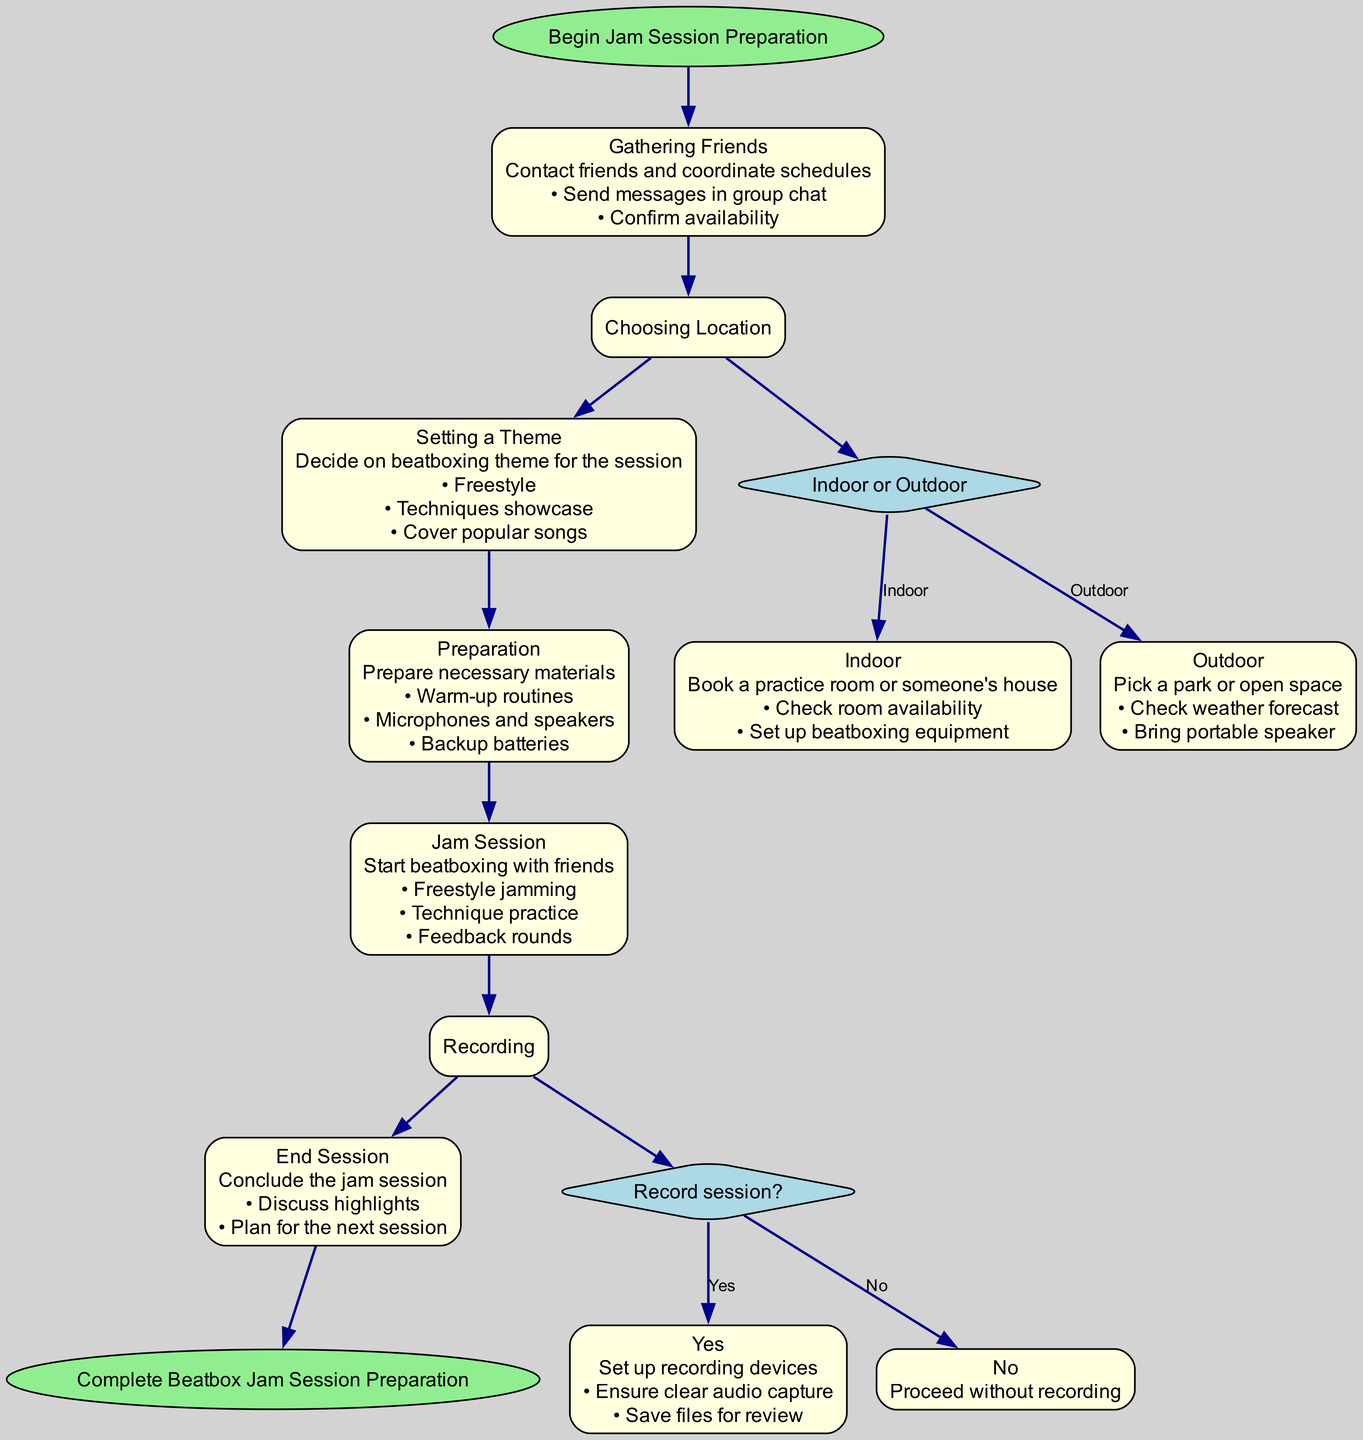What is the first step in the jam session preparation? The flow chart starts with the node labeled "Start," which contains the action "Begin Jam Session Preparation." Therefore, the first step is at the "Start" node, indicating the initiation of the preparation process.
Answer: Begin Jam Session Preparation How many steps are there before the "Recording" decision? By tracing the flow from the "Start" node to the "Recording" decision node, we identify the steps: "Gathering Friends," "Choosing Location," "Setting a Theme," and "Preparation." This totals four steps before reaching the "Recording" decision node.
Answer: 4 What are the two options available after the "Choosing Location" decision? The decision labeled "Choosing Location" has two branches labeled "Indoor" and "Outdoor." Each option represents a different action pertaining to the location for the jam session.
Answer: Indoor, Outdoor What is the action taken if the decision is "Yes" for the recording? If the decision for recording is "Yes," the action linked to that option is to "Set up recording devices." This step involves preparing the necessary equipment for capturing the session sound.
Answer: Set up recording devices What should you do if the chosen location is "Outdoor"? If "Outdoor" is the chosen option, the corresponding action is to "Pick a park or open space." This indicates the action taken when the outdoor location is decided for the jam session.
Answer: Pick a park or open space How does the session conclude after the "Jam Session"? After the "Jam Session" node, the next step leads to "End Session." The action here is to "Conclude the jam session," which means wrapping up the session activities.
Answer: Conclude the jam session What activities are included in the "Jam Session"? The "Jam Session" node details several activities, including "Freestyle jamming," "Technique practice," and "Feedback rounds." These activities represent the core components of the jam session itself.
Answer: Freestyle jamming, Technique practice, Feedback rounds How is the flow directed after "Preparation"? The flow continues directly from "Preparation" to "Jam Session" since these nodes are sequential in the preparation process. The direction indicates that preparation leads to the actual session.
Answer: Jam Session What is indicated if you choose not to record the session? If the decision is "No" for recording, the corresponding action is to "Proceed without recording." This means the jam session can continue without capturing it for later review.
Answer: Proceed without recording 